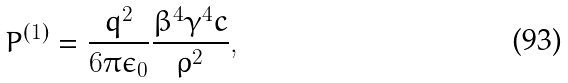<formula> <loc_0><loc_0><loc_500><loc_500>P ^ { ( 1 ) } = \frac { q ^ { 2 } } { 6 \pi \epsilon _ { 0 } } \frac { \beta ^ { 4 } \gamma ^ { 4 } c } { \rho ^ { 2 } } ,</formula> 